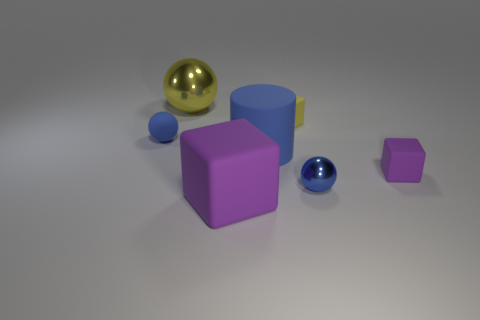Subtract all blue spheres. How many were subtracted if there are1blue spheres left? 1 Add 2 green spheres. How many objects exist? 9 Subtract all cylinders. How many objects are left? 6 Add 3 tiny shiny objects. How many tiny shiny objects are left? 4 Add 6 small red cylinders. How many small red cylinders exist? 6 Subtract 0 gray cubes. How many objects are left? 7 Subtract all large rubber cylinders. Subtract all rubber cylinders. How many objects are left? 5 